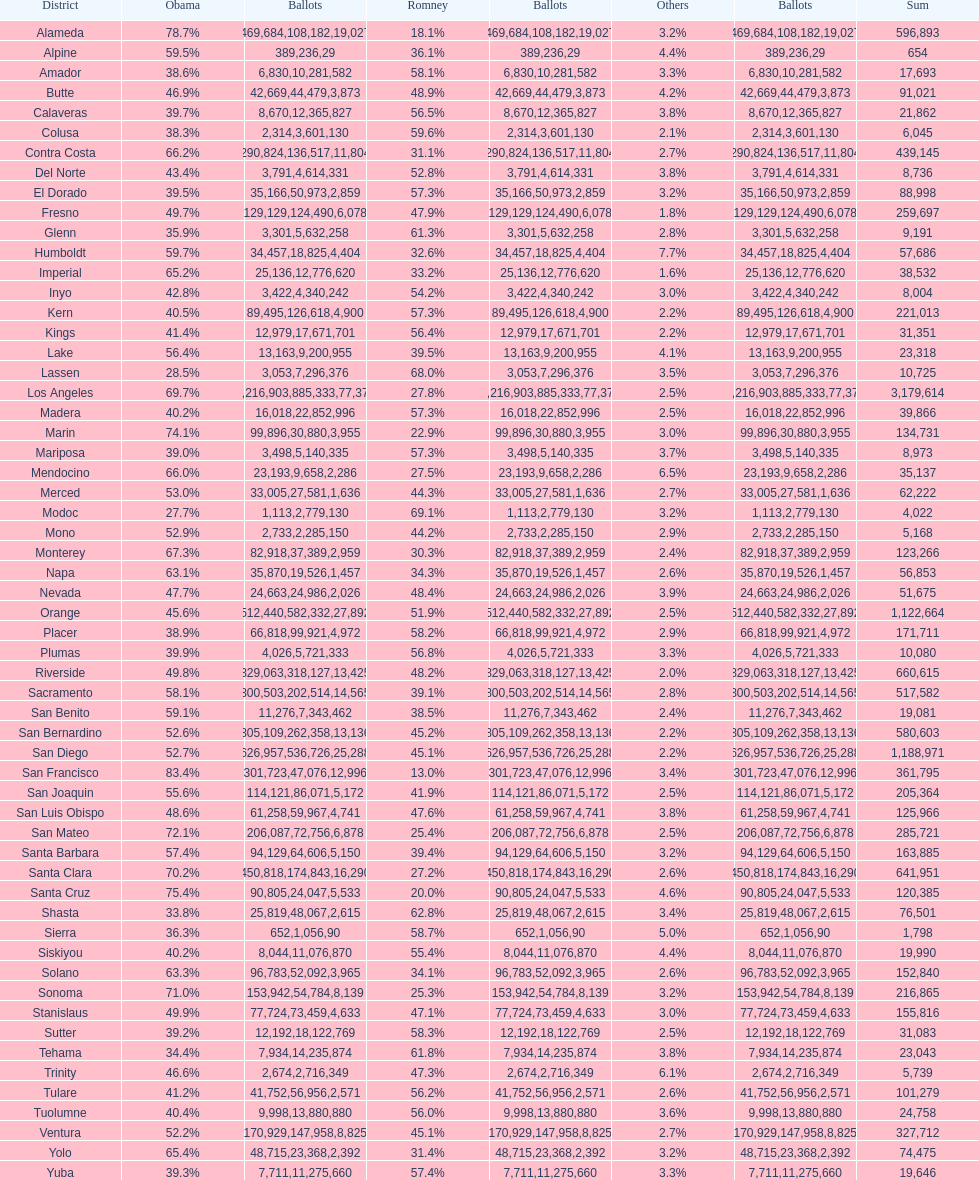What is the number of votes for obama for del norte and el dorado counties? 38957. 